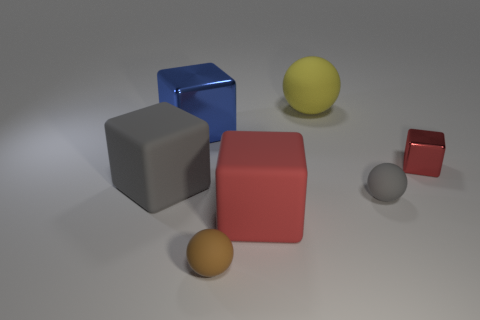Which objects in the image are reflecting light? The blue cube and the larger grey cube are reflecting light, giving them a shiny appearance. 